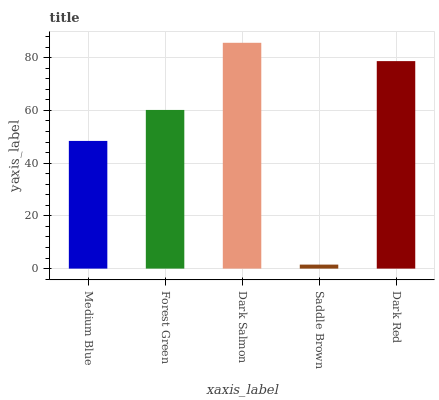Is Forest Green the minimum?
Answer yes or no. No. Is Forest Green the maximum?
Answer yes or no. No. Is Forest Green greater than Medium Blue?
Answer yes or no. Yes. Is Medium Blue less than Forest Green?
Answer yes or no. Yes. Is Medium Blue greater than Forest Green?
Answer yes or no. No. Is Forest Green less than Medium Blue?
Answer yes or no. No. Is Forest Green the high median?
Answer yes or no. Yes. Is Forest Green the low median?
Answer yes or no. Yes. Is Saddle Brown the high median?
Answer yes or no. No. Is Medium Blue the low median?
Answer yes or no. No. 